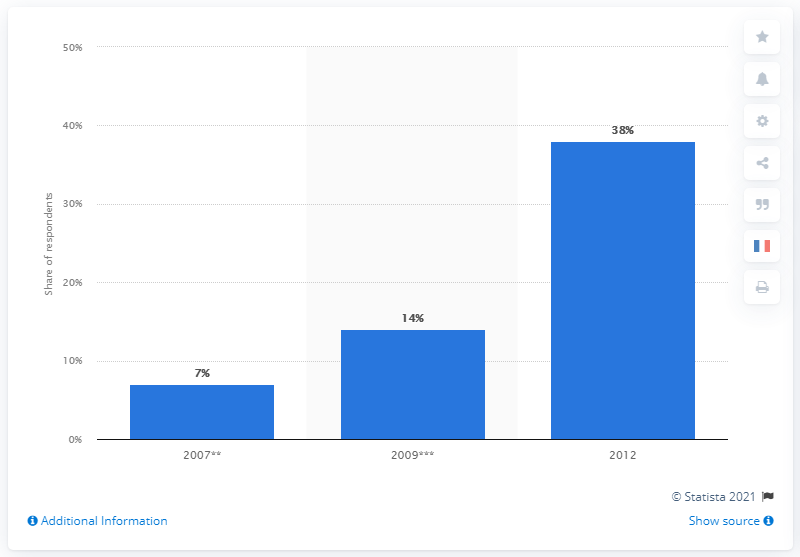Indicate a few pertinent items in this graphic. In 2012, it was reported that 38% of women in France had used sex toys. 